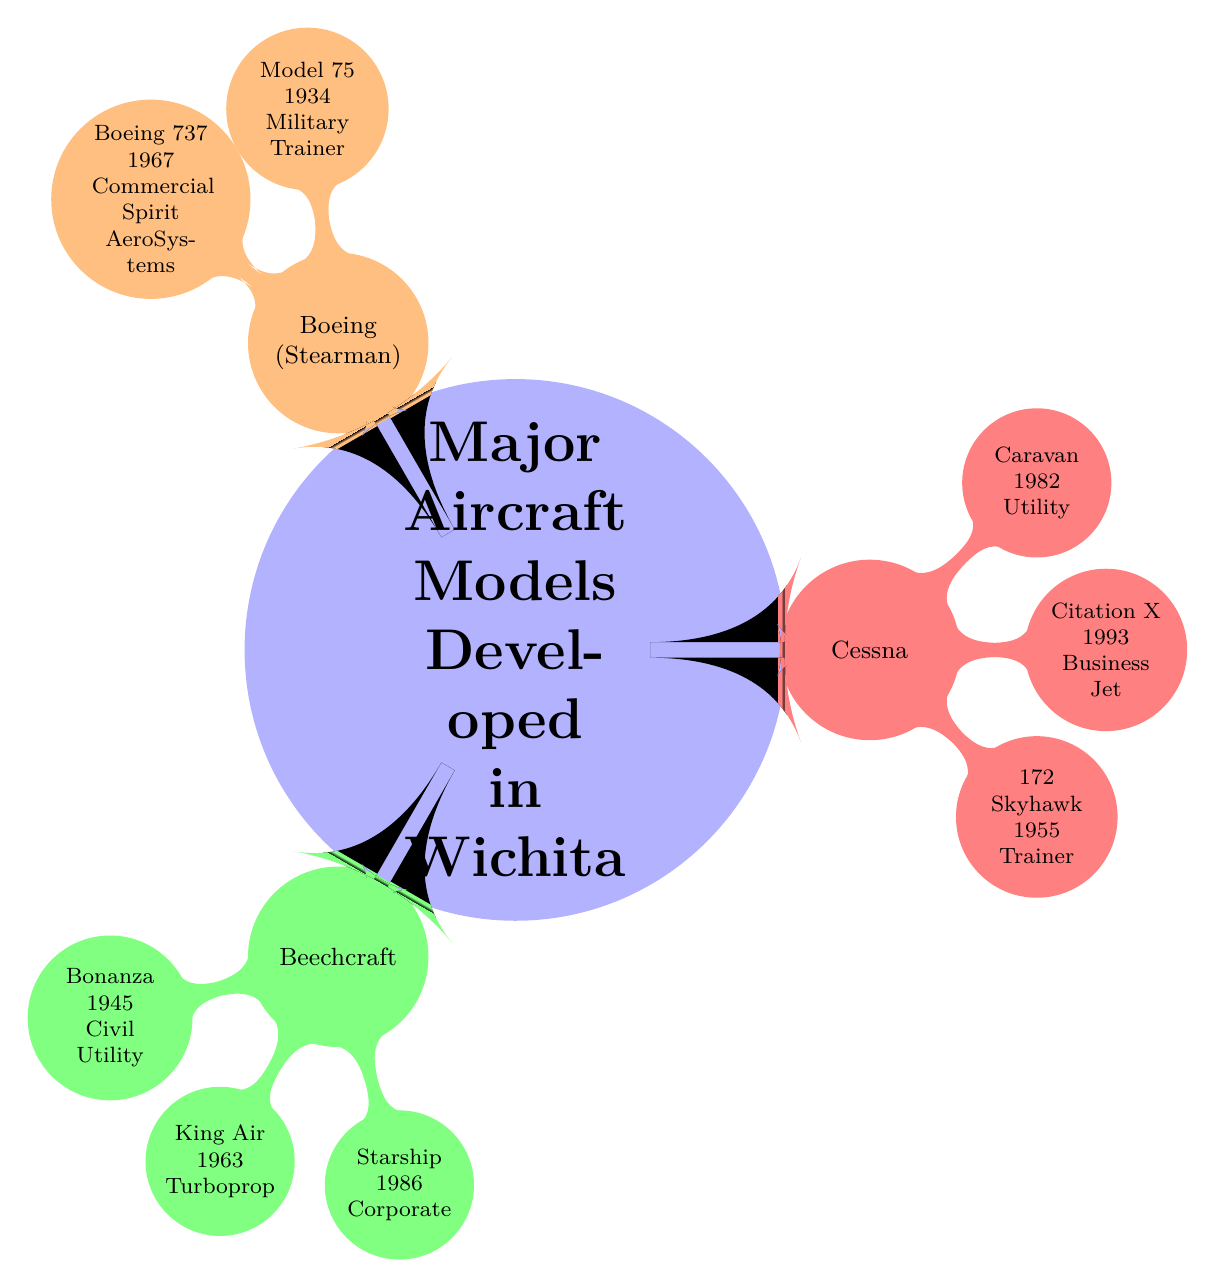What was the first flight year of the Beechcraft Bonanza? The node for Beechcraft contains a sub-node for Bonanza, which specifies that its first flight occurred in 1945.
Answer: 1945 What is the main usage for the Boeing 737? The Boeing 737 node specifies that its usage is as a "Commercial Jetliner."
Answer: Commercial Jetliner Which model was first flown in 1986? By examining the Beechcraft node, the sub-node for Starship indicates its first flight year was 1986.
Answer: Starship How many major aircraft manufacturers are shown in the diagram? The diagram has three primary manufacturers listed: Beechcraft, Cessna, and Boeing (formerly Stearman), which totals three.
Answer: 3 What is the usage category of the Cessna Citation X? The Cessna node shows that the Citation X is categorized under "Business Jet."
Answer: Business Jet Which aircraft model developed in Wichita had its first flight in 1955? Examining the Cessna section, the 172 Skyhawk is noted to have its first flight in 1955.
Answer: 172 Skyhawk What significant contribution is associated with the Boeing 737? The Boeing 737 node indicates a major contribution from "Spirit AeroSystems," which is specifically tied to its development.
Answer: Spirit AeroSystems Which Beechcraft model is noted for corporate transport? The Starship under the Beechcraft node is described as being used for "Corporate Transport."
Answer: Starship What year did the Cessna Caravan have its first flight? The Cessna node specifies that the Caravan's first flight occurred in 1982.
Answer: 1982 